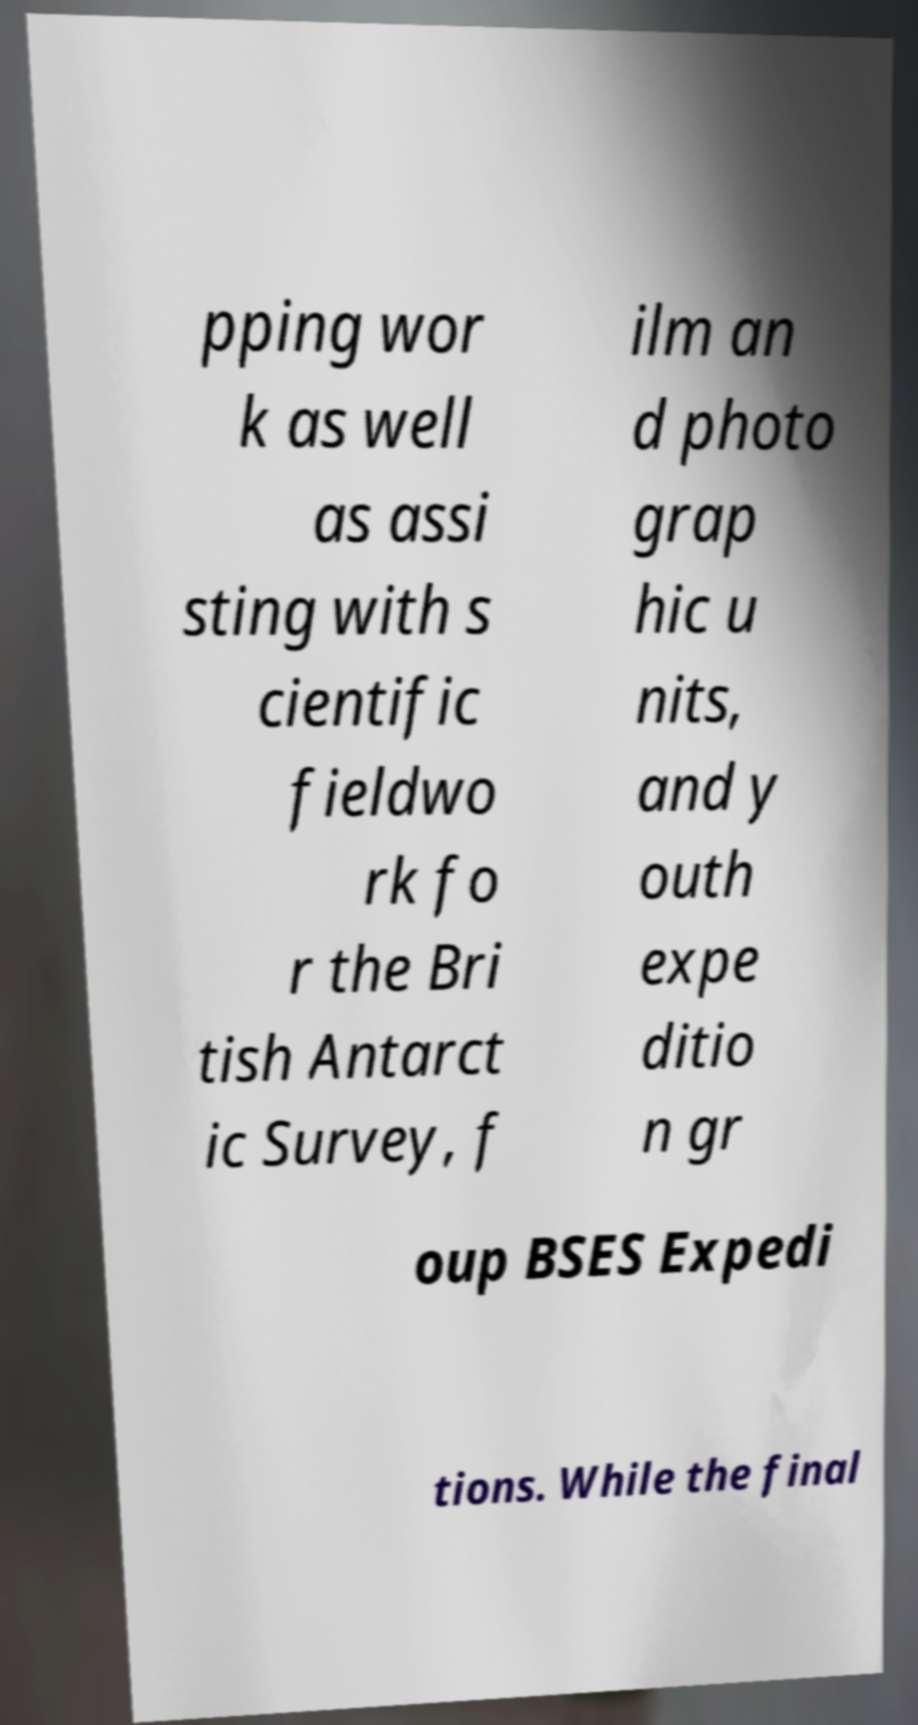Please identify and transcribe the text found in this image. pping wor k as well as assi sting with s cientific fieldwo rk fo r the Bri tish Antarct ic Survey, f ilm an d photo grap hic u nits, and y outh expe ditio n gr oup BSES Expedi tions. While the final 